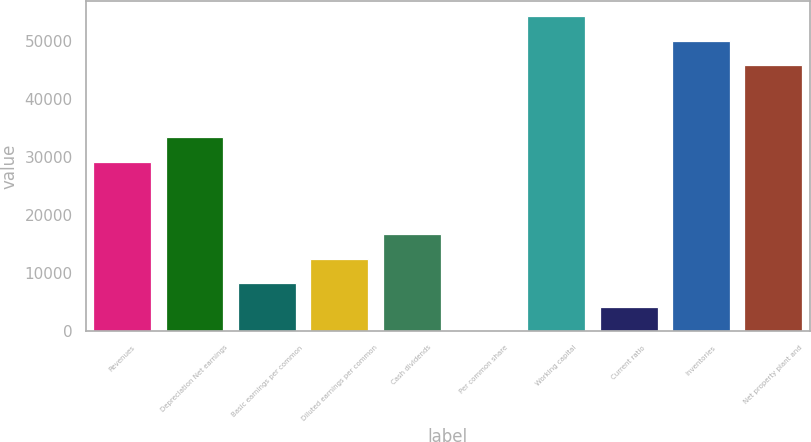Convert chart to OTSL. <chart><loc_0><loc_0><loc_500><loc_500><bar_chart><fcel>Revenues<fcel>Depreciation Net earnings<fcel>Basic earnings per common<fcel>Diluted earnings per common<fcel>Cash dividends<fcel>Per common share<fcel>Working capital<fcel>Current ratio<fcel>Inventories<fcel>Net property plant and<nl><fcel>29214<fcel>33387.3<fcel>8347.35<fcel>12520.7<fcel>16694<fcel>0.69<fcel>54254<fcel>4174.02<fcel>50080.7<fcel>45907.3<nl></chart> 